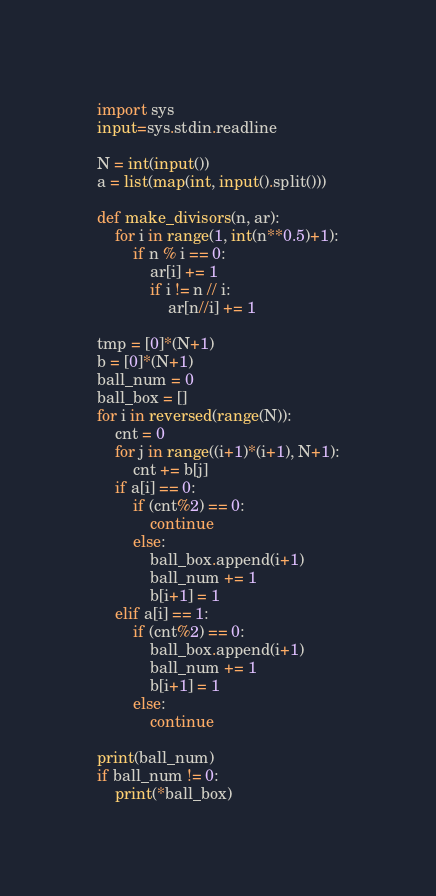Convert code to text. <code><loc_0><loc_0><loc_500><loc_500><_Python_>import sys
input=sys.stdin.readline

N = int(input())
a = list(map(int, input().split()))

def make_divisors(n, ar):
    for i in range(1, int(n**0.5)+1):
        if n % i == 0:
            ar[i] += 1
            if i != n // i:
                ar[n//i] += 1

tmp = [0]*(N+1)
b = [0]*(N+1)
ball_num = 0
ball_box = []
for i in reversed(range(N)):
    cnt = 0
    for j in range((i+1)*(i+1), N+1):
        cnt += b[j]
    if a[i] == 0:
        if (cnt%2) == 0:
            continue
        else:
            ball_box.append(i+1)
            ball_num += 1
            b[i+1] = 1
    elif a[i] == 1:
        if (cnt%2) == 0:
            ball_box.append(i+1)
            ball_num += 1
            b[i+1] = 1
        else:
            continue

print(ball_num)
if ball_num != 0:
    print(*ball_box)</code> 